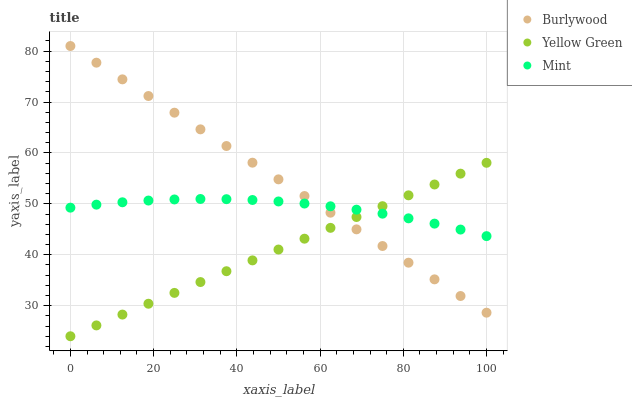Does Yellow Green have the minimum area under the curve?
Answer yes or no. Yes. Does Burlywood have the maximum area under the curve?
Answer yes or no. Yes. Does Mint have the minimum area under the curve?
Answer yes or no. No. Does Mint have the maximum area under the curve?
Answer yes or no. No. Is Yellow Green the smoothest?
Answer yes or no. Yes. Is Mint the roughest?
Answer yes or no. Yes. Is Mint the smoothest?
Answer yes or no. No. Is Yellow Green the roughest?
Answer yes or no. No. Does Yellow Green have the lowest value?
Answer yes or no. Yes. Does Mint have the lowest value?
Answer yes or no. No. Does Burlywood have the highest value?
Answer yes or no. Yes. Does Yellow Green have the highest value?
Answer yes or no. No. Does Burlywood intersect Yellow Green?
Answer yes or no. Yes. Is Burlywood less than Yellow Green?
Answer yes or no. No. Is Burlywood greater than Yellow Green?
Answer yes or no. No. 